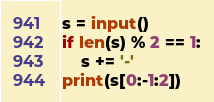<code> <loc_0><loc_0><loc_500><loc_500><_Python_>s = input()
if len(s) % 2 == 1:
    s += '-'
print(s[0:-1:2])
</code> 